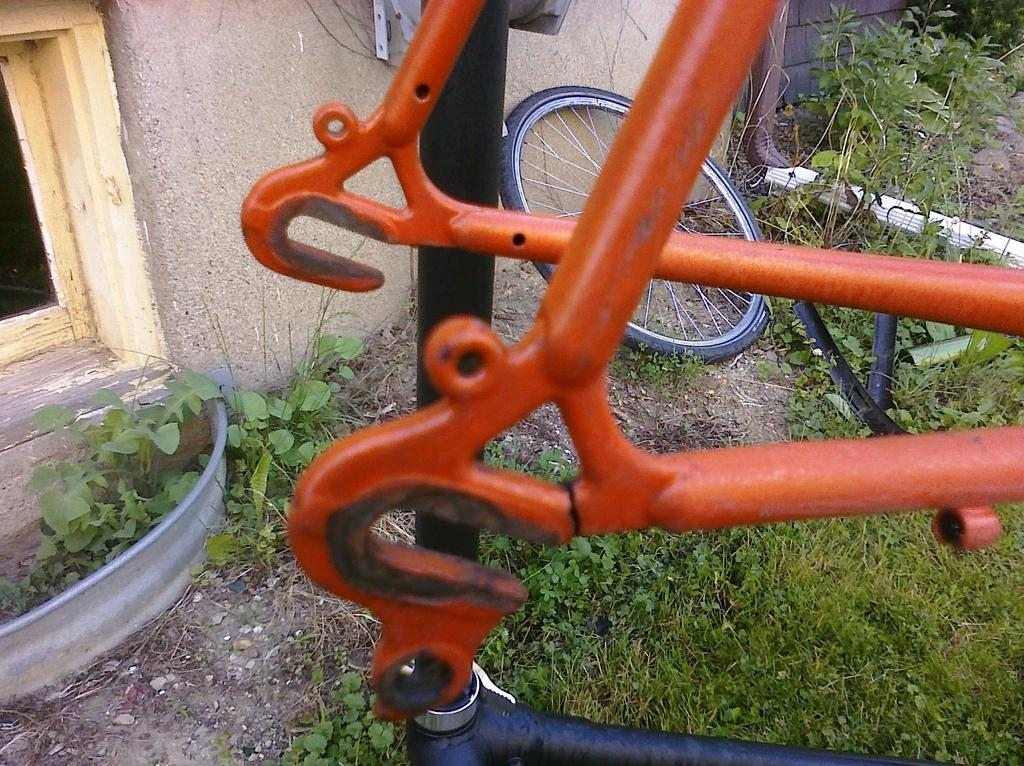What type of object is highlighted in the image? There is a metallic object highlighted in the image. What can be seen beneath the metallic object? The ground is visible in the image. What other feature is present in the image related to the metallic object? There is a wheel in the image. Can you describe the surrounding environment in the image? There are other metallic objects, a wall, a door, plants, and grass visible in the image. What type of shoes can be seen near the lake in the morning? There is no lake or shoes present in the image; it features a metallic object, a wheel, and other surrounding elements. 